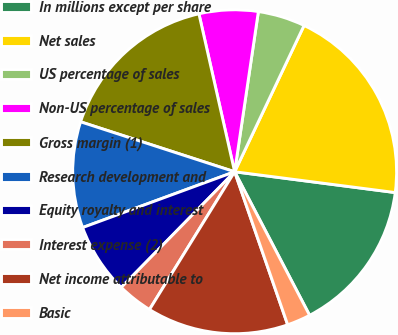<chart> <loc_0><loc_0><loc_500><loc_500><pie_chart><fcel>In millions except per share<fcel>Net sales<fcel>US percentage of sales<fcel>Non-US percentage of sales<fcel>Gross margin (1)<fcel>Research development and<fcel>Equity royalty and interest<fcel>Interest expense (2)<fcel>Net income attributable to<fcel>Basic<nl><fcel>15.29%<fcel>20.0%<fcel>4.71%<fcel>5.88%<fcel>16.47%<fcel>10.59%<fcel>7.06%<fcel>3.53%<fcel>14.12%<fcel>2.35%<nl></chart> 